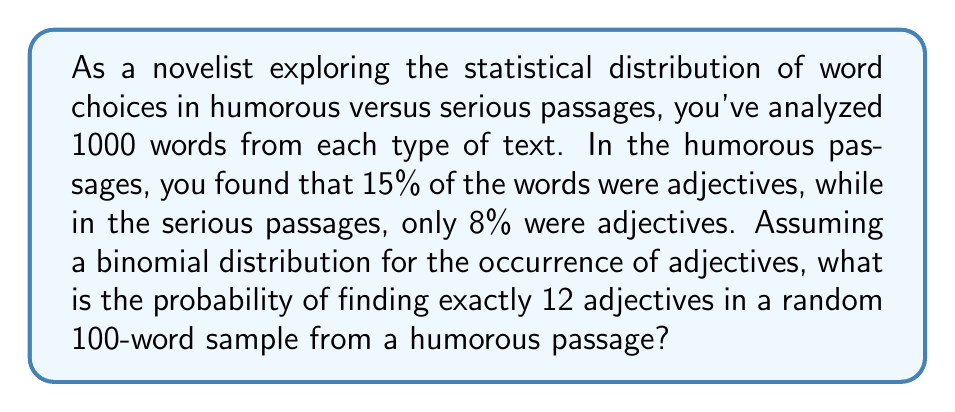Show me your answer to this math problem. To solve this problem, we'll use the binomial probability distribution formula:

$$ P(X = k) = \binom{n}{k} p^k (1-p)^{n-k} $$

Where:
- $n$ is the number of trials (words in our sample)
- $k$ is the number of successes (adjectives we're looking for)
- $p$ is the probability of success on each trial (proportion of adjectives in humorous passages)

Given:
- $n = 100$ (words in the sample)
- $k = 12$ (adjectives we're looking for)
- $p = 0.15$ (15% of words are adjectives in humorous passages)

Step 1: Calculate the binomial coefficient
$$ \binom{100}{12} = \frac{100!}{12!(100-12)!} = 100891344545564193334812497256 $$

Step 2: Calculate $p^k$
$$ 0.15^{12} \approx 5.3644 \times 10^{-11} $$

Step 3: Calculate $(1-p)^{n-k}$
$$ 0.85^{88} \approx 1.1019 \times 10^{-7} $$

Step 4: Multiply all parts together
$$ P(X = 12) = 100891344545564193334812497256 \times 5.3644 \times 10^{-11} \times 1.1019 \times 10^{-7} $$
$$ \approx 0.0595 $$

Therefore, the probability of finding exactly 12 adjectives in a 100-word sample from a humorous passage is approximately 0.0595 or 5.95%.
Answer: 0.0595 